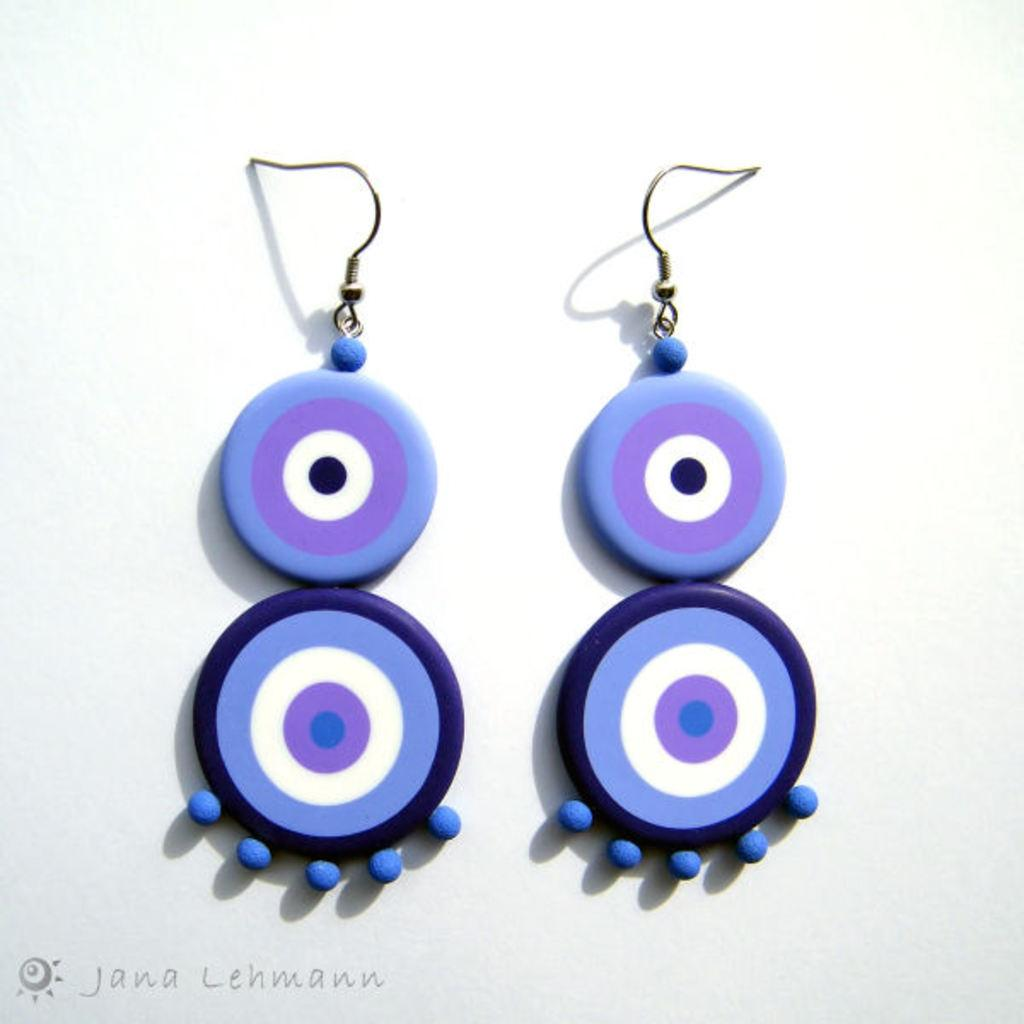What is located in the foreground of the image? There are earrings in the foreground of the image. What is the color of the surface the earrings are on? The surface the earrings are on is white. What rule is being taught in the image? There is no indication in the image that a rule is being taught. How many books are visible in the image? There are no books present in the image. 